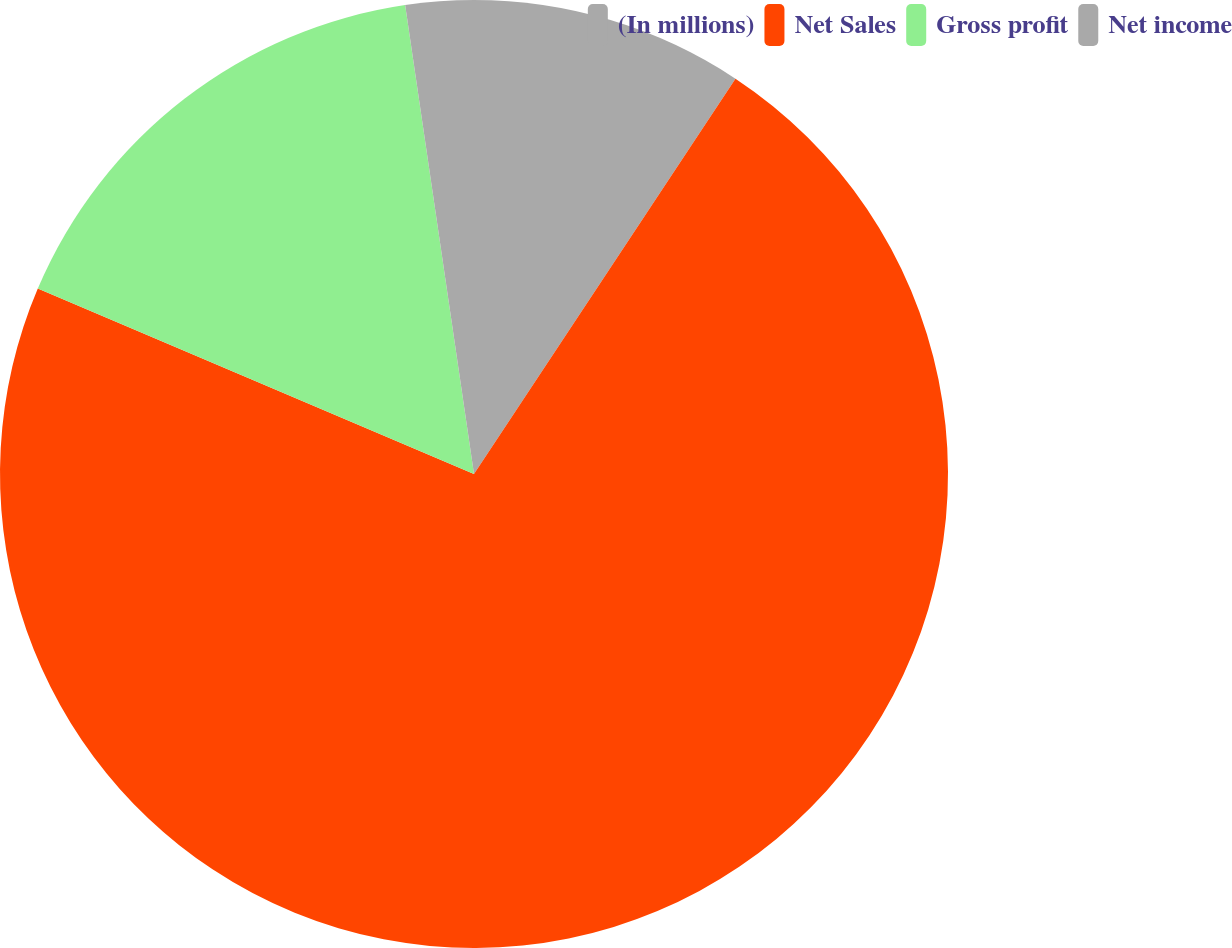<chart> <loc_0><loc_0><loc_500><loc_500><pie_chart><fcel>(In millions)<fcel>Net Sales<fcel>Gross profit<fcel>Net income<nl><fcel>9.3%<fcel>72.1%<fcel>16.28%<fcel>2.32%<nl></chart> 